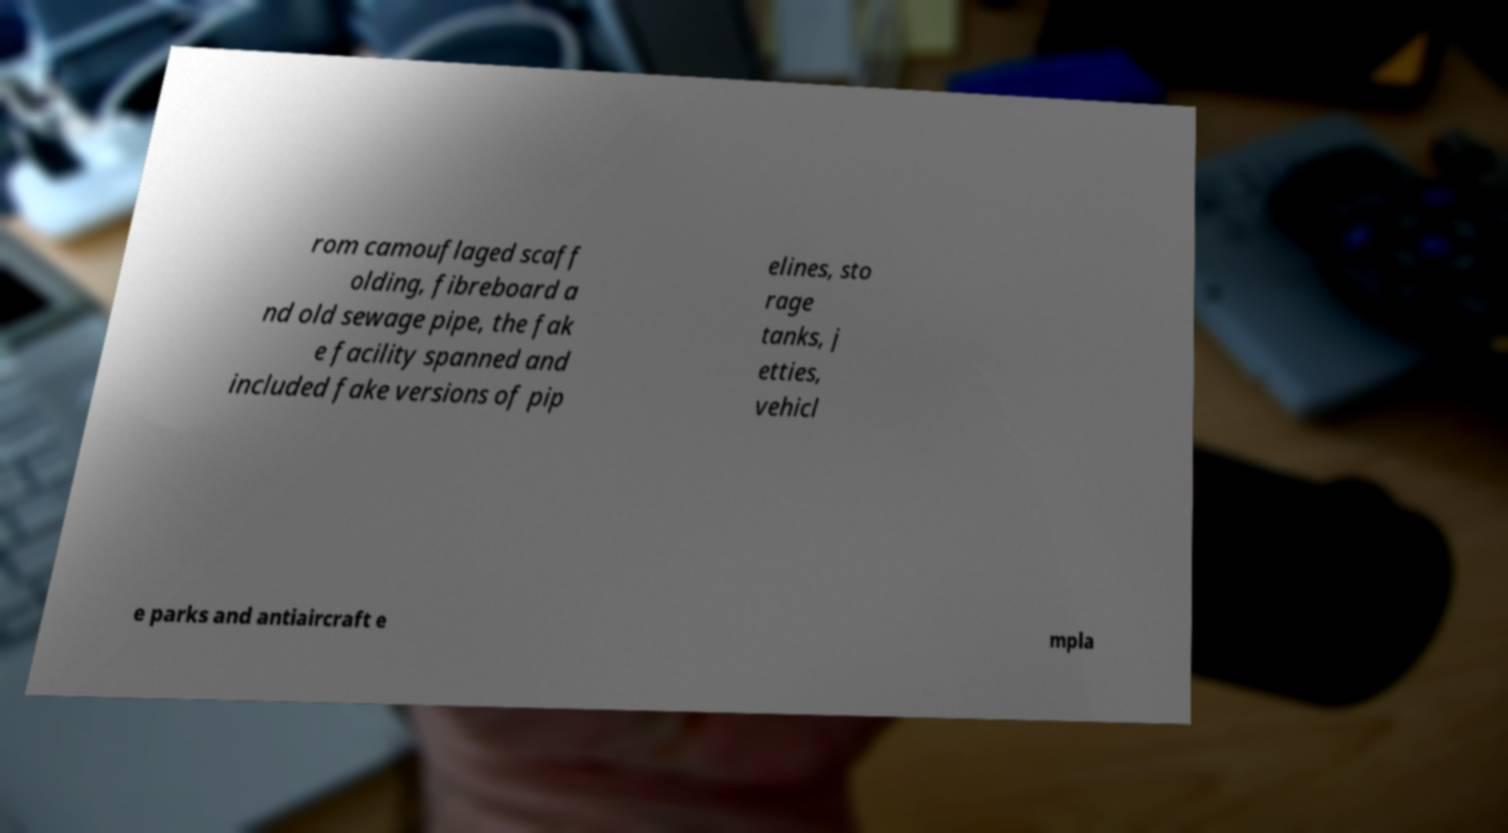Can you read and provide the text displayed in the image?This photo seems to have some interesting text. Can you extract and type it out for me? rom camouflaged scaff olding, fibreboard a nd old sewage pipe, the fak e facility spanned and included fake versions of pip elines, sto rage tanks, j etties, vehicl e parks and antiaircraft e mpla 